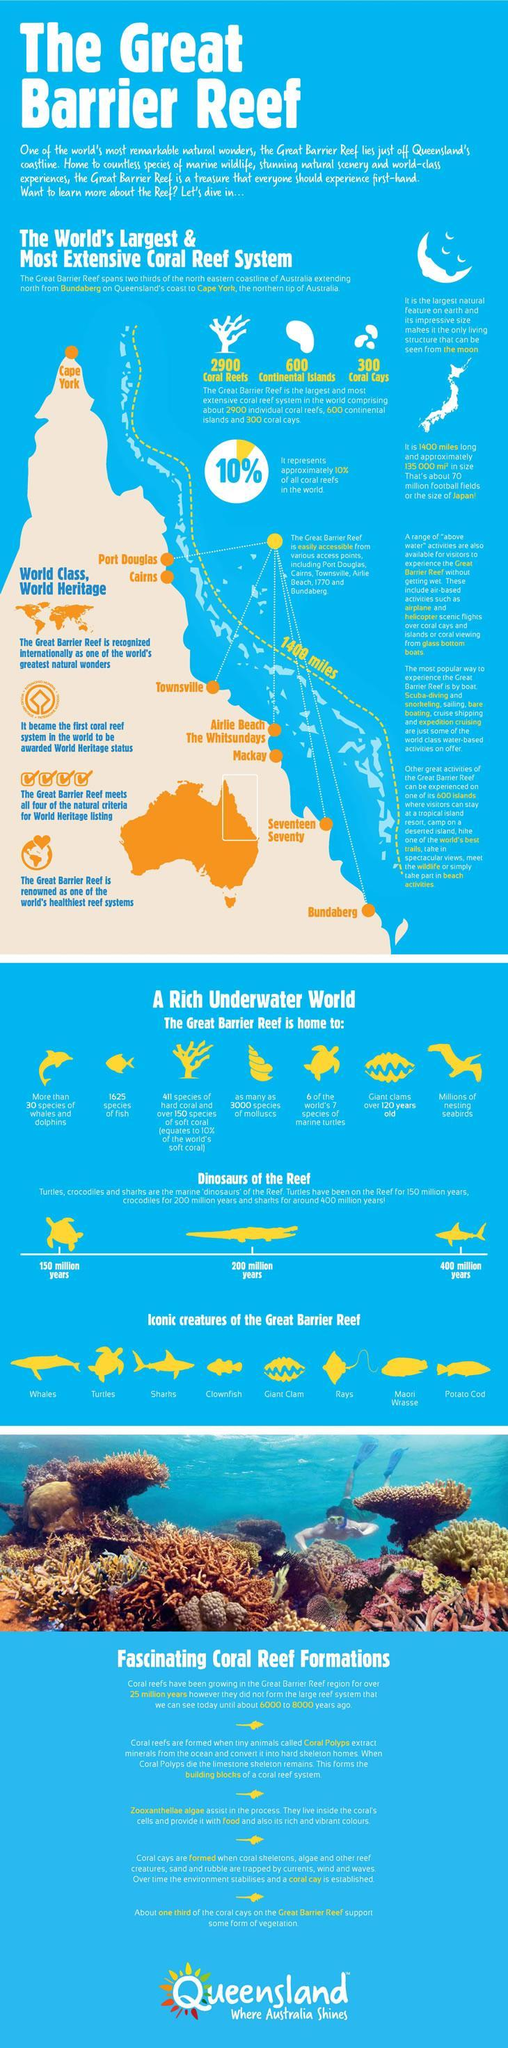which dinosaur of the reef has been in the reef for the longest period
Answer the question with a short phrase. sharks what is the size of Japan the great barrier reef how many continental islands are there 600 which access point is at the tip of the reef cape york how many access points are there 8 how many species of marine turtles are found in the reef 6 